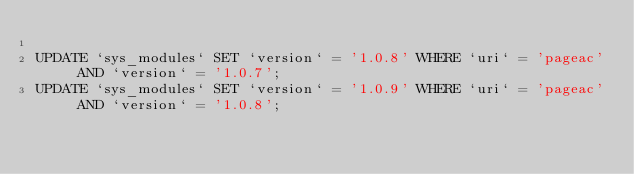<code> <loc_0><loc_0><loc_500><loc_500><_SQL_>
UPDATE `sys_modules` SET `version` = '1.0.8' WHERE `uri` = 'pageac' AND `version` = '1.0.7';
UPDATE `sys_modules` SET `version` = '1.0.9' WHERE `uri` = 'pageac' AND `version` = '1.0.8';

</code> 